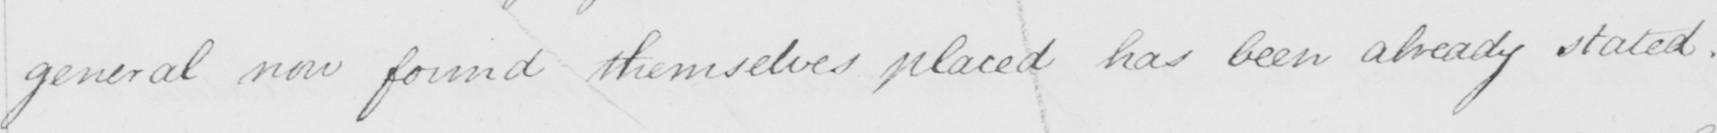Can you tell me what this handwritten text says? general now found themselves placed has been already stated . 